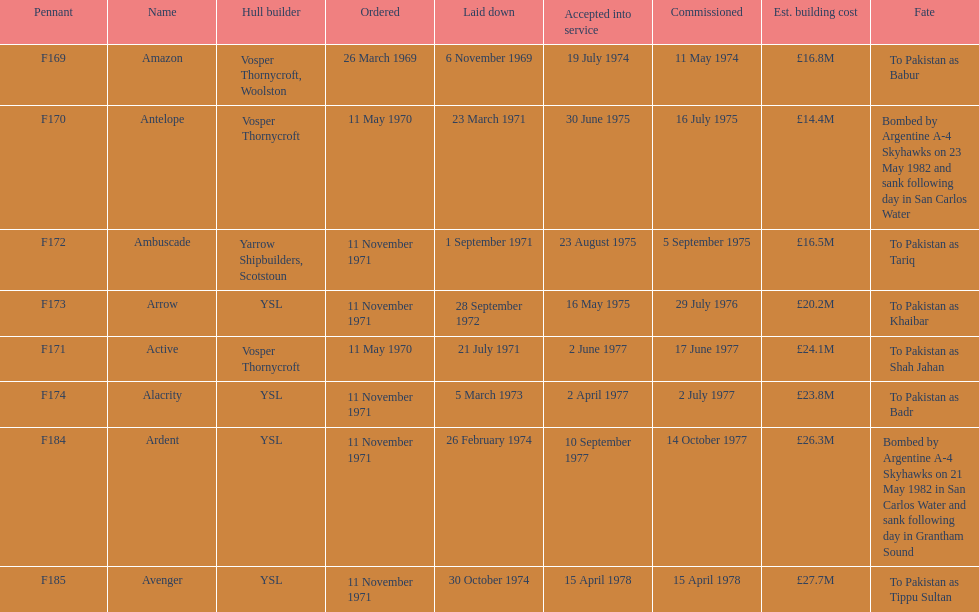How many boats costed less than £20m to build? 3. 